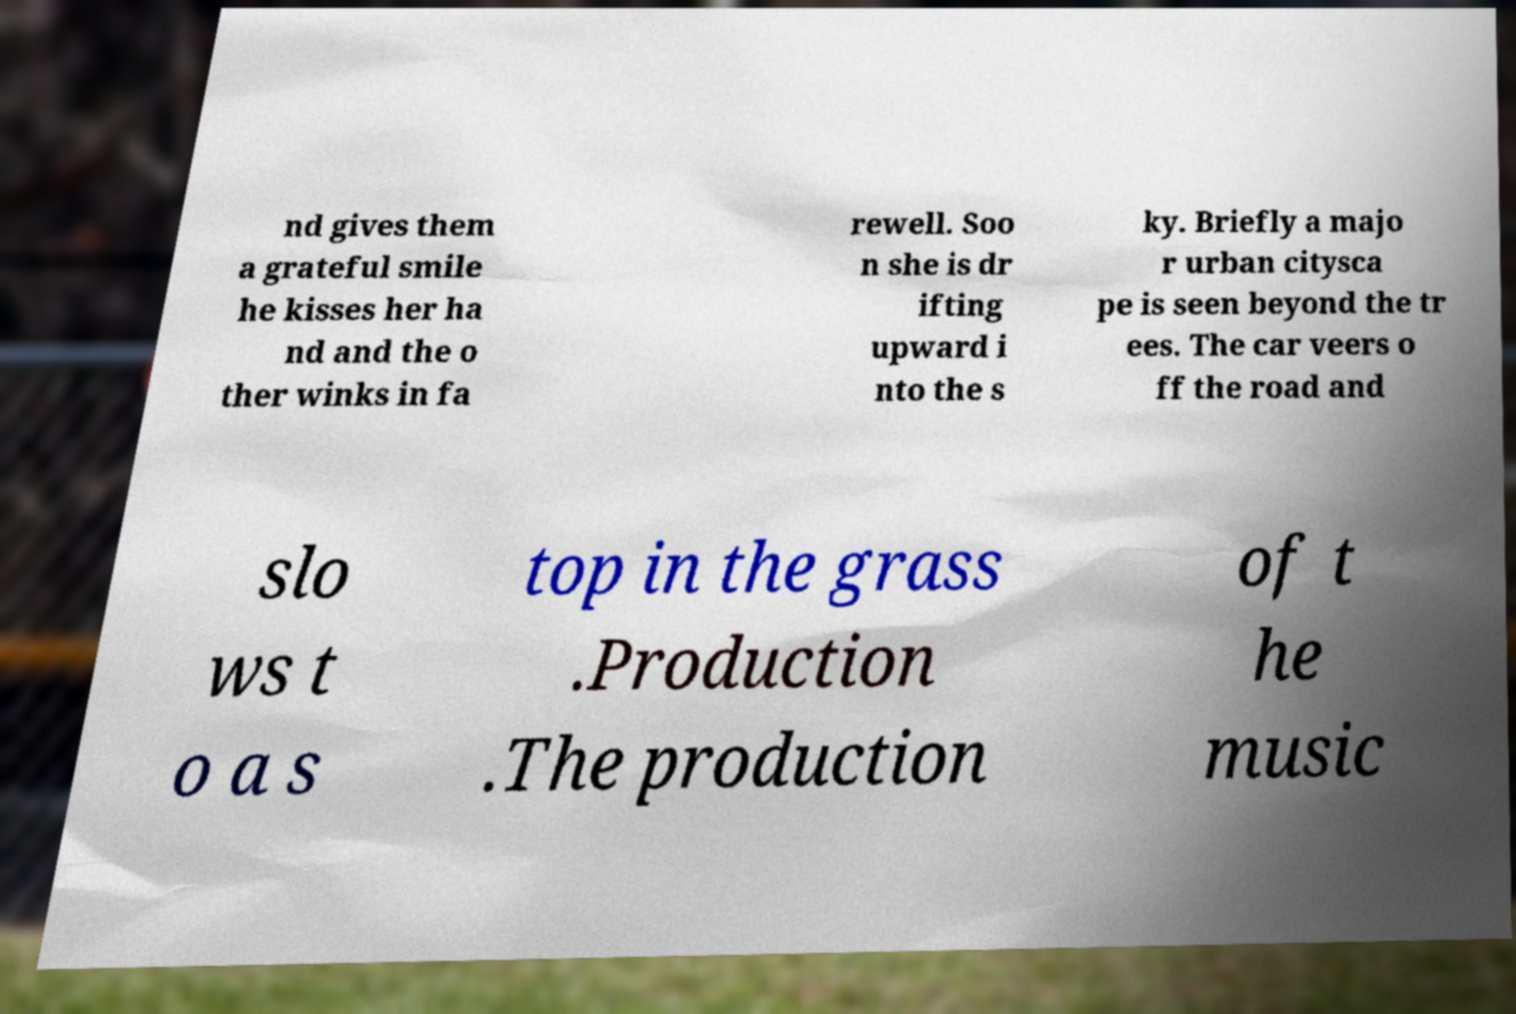Could you extract and type out the text from this image? nd gives them a grateful smile he kisses her ha nd and the o ther winks in fa rewell. Soo n she is dr ifting upward i nto the s ky. Briefly a majo r urban citysca pe is seen beyond the tr ees. The car veers o ff the road and slo ws t o a s top in the grass .Production .The production of t he music 